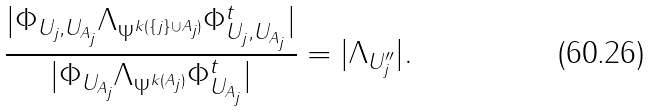Convert formula to latex. <formula><loc_0><loc_0><loc_500><loc_500>\frac { | \Phi _ { U _ { j } , U _ { A _ { j } } } \Lambda _ { \Psi ^ { k ( \{ j \} \cup A _ { j } ) } } \Phi _ { U _ { j } , U _ { A _ { j } } } ^ { t } | } { | \Phi _ { U _ { A _ { j } } } \Lambda _ { \Psi ^ { k ( A _ { j } ) } } \Phi _ { U _ { A _ { j } } } ^ { t } | } = | \Lambda _ { U ^ { \prime \prime } _ { j } } | .</formula> 